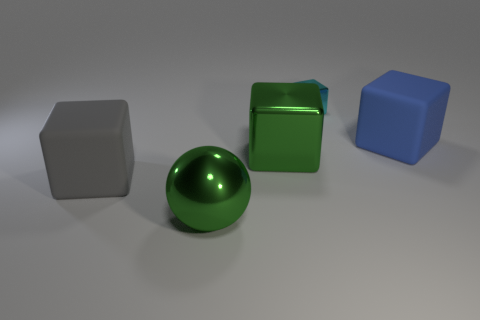Subtract 1 cubes. How many cubes are left? 3 Add 3 small gray cubes. How many objects exist? 8 Subtract all spheres. How many objects are left? 4 Subtract all big cubes. Subtract all large yellow shiny spheres. How many objects are left? 2 Add 2 large matte objects. How many large matte objects are left? 4 Add 5 rubber objects. How many rubber objects exist? 7 Subtract 0 gray cylinders. How many objects are left? 5 